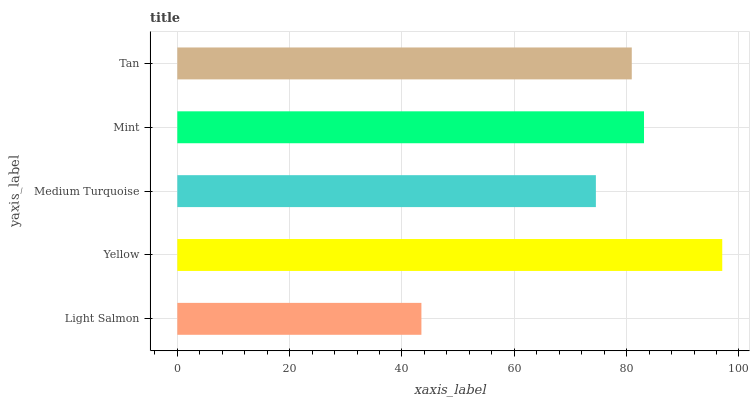Is Light Salmon the minimum?
Answer yes or no. Yes. Is Yellow the maximum?
Answer yes or no. Yes. Is Medium Turquoise the minimum?
Answer yes or no. No. Is Medium Turquoise the maximum?
Answer yes or no. No. Is Yellow greater than Medium Turquoise?
Answer yes or no. Yes. Is Medium Turquoise less than Yellow?
Answer yes or no. Yes. Is Medium Turquoise greater than Yellow?
Answer yes or no. No. Is Yellow less than Medium Turquoise?
Answer yes or no. No. Is Tan the high median?
Answer yes or no. Yes. Is Tan the low median?
Answer yes or no. Yes. Is Medium Turquoise the high median?
Answer yes or no. No. Is Medium Turquoise the low median?
Answer yes or no. No. 